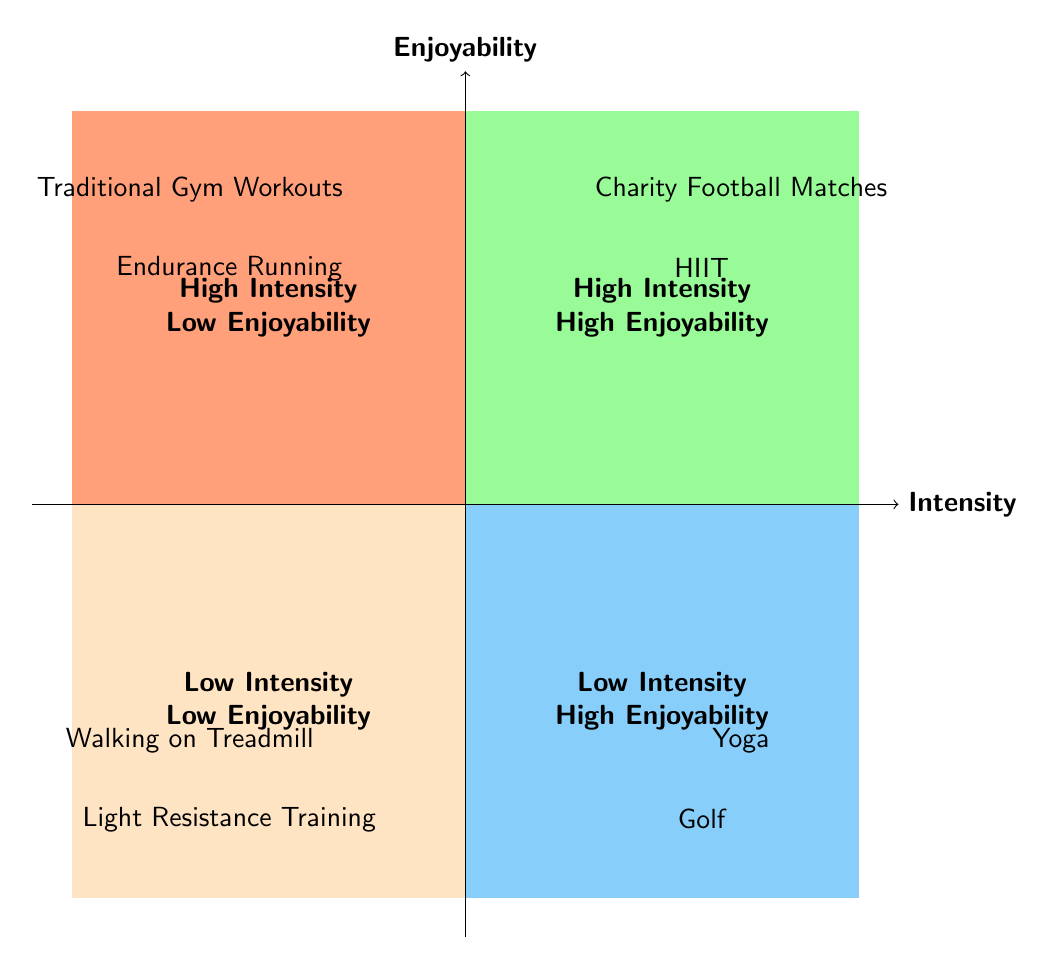What activities fall under High Intensity - High Enjoyability? The diagram shows two activities categorized under High Intensity - High Enjoyability: Charity Football Matches and High-Intensity Interval Training (HIIT).
Answer: Charity Football Matches, High-Intensity Interval Training Which category contains Yoga? Yoga is listed under Low Intensity - High Enjoyability in the diagram, indicating that it is a low-intensity activity but is enjoyed greatly.
Answer: Low Intensity - High Enjoyability How many activities are in the High Intensity - Low Enjoyability quadrant? The diagram indicates that there are two activities in the High Intensity - Low Enjoyability quadrant: Traditional Gym Workouts and Endurance Running.
Answer: 2 Which activity is both low intensity and lacks enjoyment? The diagram specifies that the Walking on Treadmill is categorized under Low Intensity - Low Enjoyability, making it the activity that fits both criteria.
Answer: Walking on Treadmill Is there any activity listed under Low Intensity - High Enjoyability? Yes, there are two activities, Yoga and Golf, that are categorized under Low Intensity - High Enjoyability, indicating that they are both enjoyable and of low intensity.
Answer: Yes, Yoga and Golf What is a reason for choosing High-Intensity Interval Training (HIIT)? The diagram states that the reason for choosing HIIT is that it allows quick sessions while maintaining peak fitness levels and preventing boredom.
Answer: Quick sessions maintaining peak fitness Which quadrant has activities that promote flexibility and relaxation? The quadrant titled Low Intensity - High Enjoyability contains activities like Yoga, which is known for promoting flexibility and relaxation.
Answer: Low Intensity - High Enjoyability What common characteristic do Traditional Gym Workouts and Endurance Running share? Both activities are categorized under High Intensity - Low Enjoyability, signifying they are high-intensity but not very enjoyable.
Answer: High Intensity - Low Enjoyability What is the primary reason for participating in Charity Football Matches? The diagram indicates that Charity Football Matches allow for reunions with former teammates and engagement with fans, making them enjoyable and social.
Answer: Reuniting with former teammates and engaging with fans 